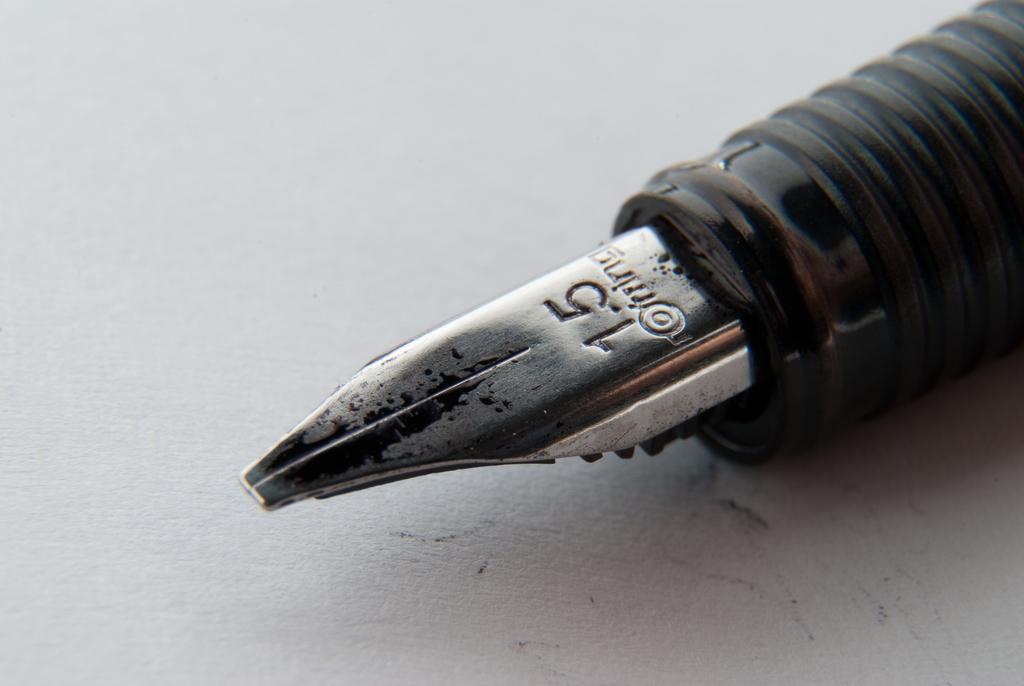Can you describe this image briefly? In this image, we can see an ink pen on the white surface. 